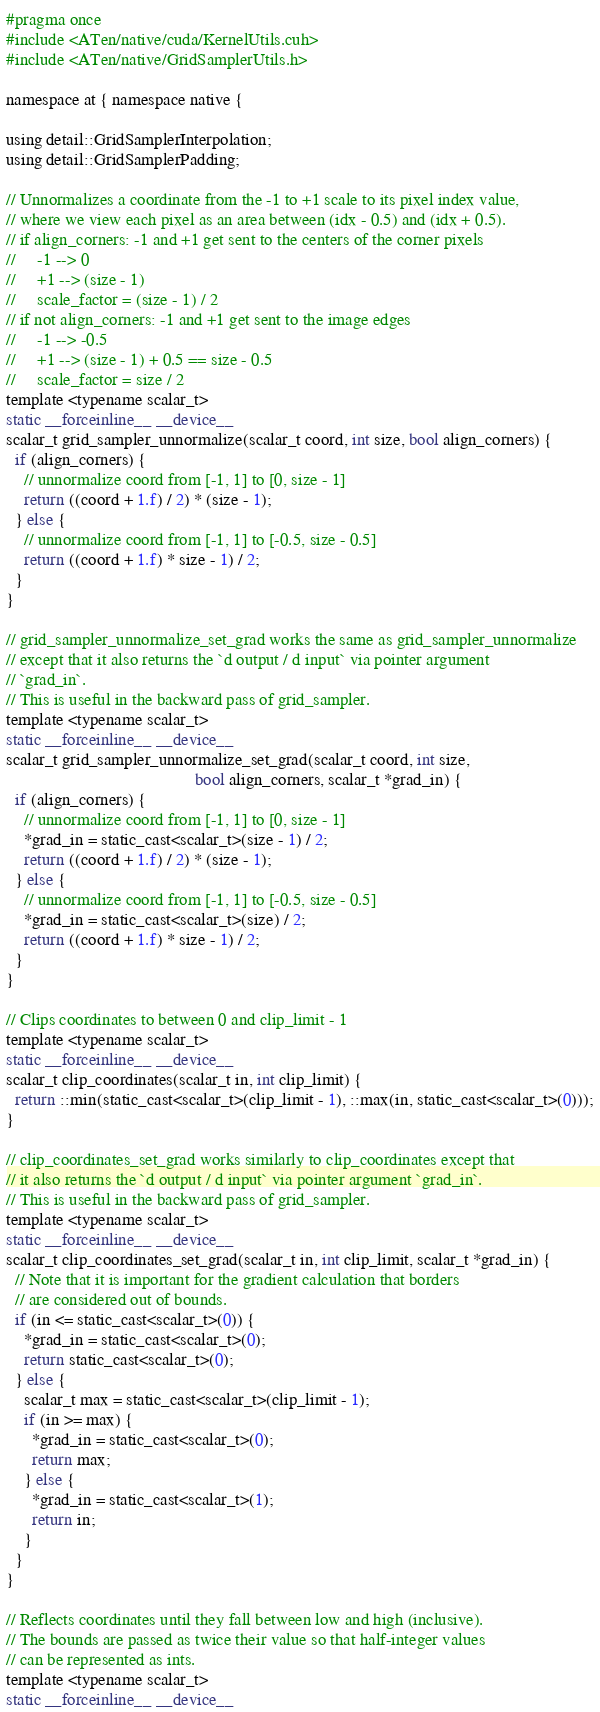<code> <loc_0><loc_0><loc_500><loc_500><_Cuda_>#pragma once
#include <ATen/native/cuda/KernelUtils.cuh>
#include <ATen/native/GridSamplerUtils.h>

namespace at { namespace native {

using detail::GridSamplerInterpolation;
using detail::GridSamplerPadding;

// Unnormalizes a coordinate from the -1 to +1 scale to its pixel index value,
// where we view each pixel as an area between (idx - 0.5) and (idx + 0.5).
// if align_corners: -1 and +1 get sent to the centers of the corner pixels
//     -1 --> 0
//     +1 --> (size - 1)
//     scale_factor = (size - 1) / 2
// if not align_corners: -1 and +1 get sent to the image edges
//     -1 --> -0.5
//     +1 --> (size - 1) + 0.5 == size - 0.5
//     scale_factor = size / 2
template <typename scalar_t>
static __forceinline__ __device__
scalar_t grid_sampler_unnormalize(scalar_t coord, int size, bool align_corners) {
  if (align_corners) {
    // unnormalize coord from [-1, 1] to [0, size - 1]
    return ((coord + 1.f) / 2) * (size - 1);
  } else {
    // unnormalize coord from [-1, 1] to [-0.5, size - 0.5]
    return ((coord + 1.f) * size - 1) / 2;
  }
}

// grid_sampler_unnormalize_set_grad works the same as grid_sampler_unnormalize
// except that it also returns the `d output / d input` via pointer argument
// `grad_in`.
// This is useful in the backward pass of grid_sampler.
template <typename scalar_t>
static __forceinline__ __device__
scalar_t grid_sampler_unnormalize_set_grad(scalar_t coord, int size,
                                           bool align_corners, scalar_t *grad_in) {
  if (align_corners) {
    // unnormalize coord from [-1, 1] to [0, size - 1]
    *grad_in = static_cast<scalar_t>(size - 1) / 2;
    return ((coord + 1.f) / 2) * (size - 1);
  } else {
    // unnormalize coord from [-1, 1] to [-0.5, size - 0.5]
    *grad_in = static_cast<scalar_t>(size) / 2;
    return ((coord + 1.f) * size - 1) / 2;
  }
}

// Clips coordinates to between 0 and clip_limit - 1
template <typename scalar_t>
static __forceinline__ __device__
scalar_t clip_coordinates(scalar_t in, int clip_limit) {
  return ::min(static_cast<scalar_t>(clip_limit - 1), ::max(in, static_cast<scalar_t>(0)));
}

// clip_coordinates_set_grad works similarly to clip_coordinates except that
// it also returns the `d output / d input` via pointer argument `grad_in`.
// This is useful in the backward pass of grid_sampler.
template <typename scalar_t>
static __forceinline__ __device__
scalar_t clip_coordinates_set_grad(scalar_t in, int clip_limit, scalar_t *grad_in) {
  // Note that it is important for the gradient calculation that borders
  // are considered out of bounds.
  if (in <= static_cast<scalar_t>(0)) {
    *grad_in = static_cast<scalar_t>(0);
    return static_cast<scalar_t>(0);
  } else {
    scalar_t max = static_cast<scalar_t>(clip_limit - 1);
    if (in >= max) {
      *grad_in = static_cast<scalar_t>(0);
      return max;
    } else {
      *grad_in = static_cast<scalar_t>(1);
      return in;
    }
  }
}

// Reflects coordinates until they fall between low and high (inclusive).
// The bounds are passed as twice their value so that half-integer values
// can be represented as ints.
template <typename scalar_t>
static __forceinline__ __device__</code> 